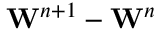Convert formula to latex. <formula><loc_0><loc_0><loc_500><loc_500>W ^ { n + 1 } - W ^ { n }</formula> 